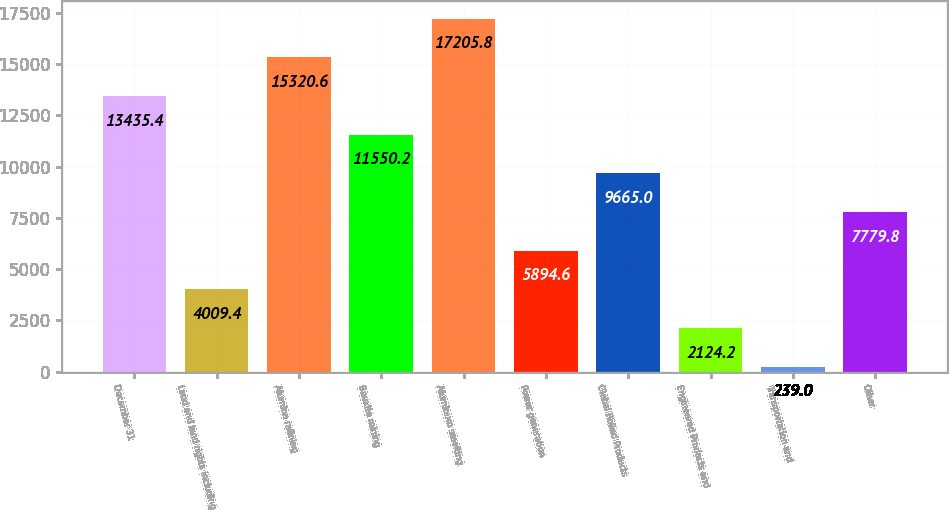Convert chart to OTSL. <chart><loc_0><loc_0><loc_500><loc_500><bar_chart><fcel>December 31<fcel>Land and land rights including<fcel>Alumina refining<fcel>Bauxite mining<fcel>Aluminum smelting<fcel>Power generation<fcel>Global Rolled Products<fcel>Engineered Products and<fcel>Transportation and<fcel>Other<nl><fcel>13435.4<fcel>4009.4<fcel>15320.6<fcel>11550.2<fcel>17205.8<fcel>5894.6<fcel>9665<fcel>2124.2<fcel>239<fcel>7779.8<nl></chart> 